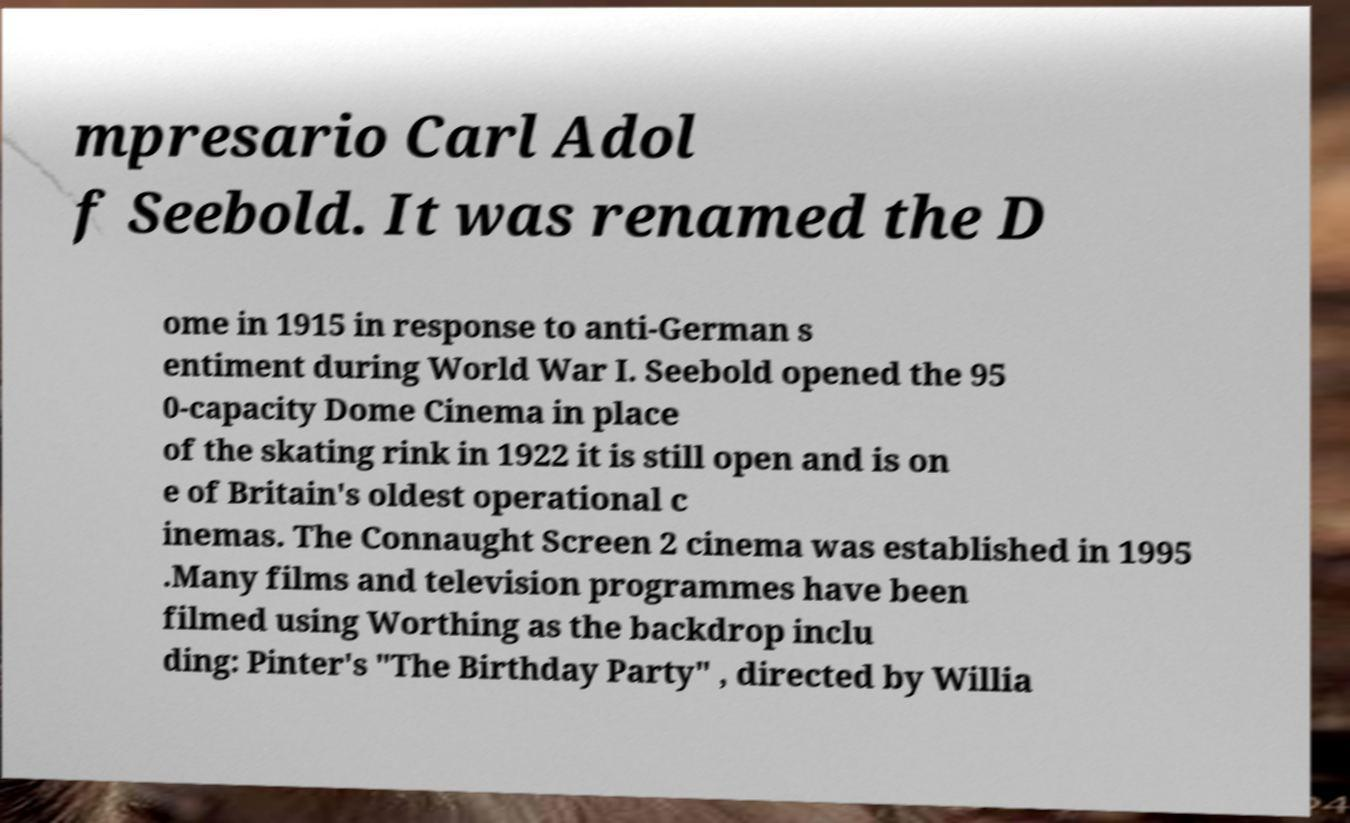For documentation purposes, I need the text within this image transcribed. Could you provide that? mpresario Carl Adol f Seebold. It was renamed the D ome in 1915 in response to anti-German s entiment during World War I. Seebold opened the 95 0-capacity Dome Cinema in place of the skating rink in 1922 it is still open and is on e of Britain's oldest operational c inemas. The Connaught Screen 2 cinema was established in 1995 .Many films and television programmes have been filmed using Worthing as the backdrop inclu ding: Pinter's "The Birthday Party" , directed by Willia 